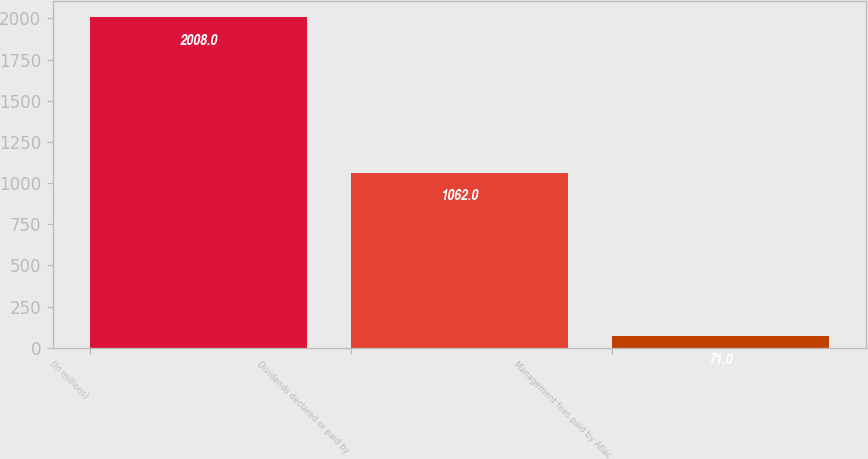Convert chart to OTSL. <chart><loc_0><loc_0><loc_500><loc_500><bar_chart><fcel>(In millions)<fcel>Dividends declared or paid by<fcel>Management fees paid by Aflac<nl><fcel>2008<fcel>1062<fcel>71<nl></chart> 